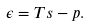<formula> <loc_0><loc_0><loc_500><loc_500>\epsilon = T s - p .</formula> 